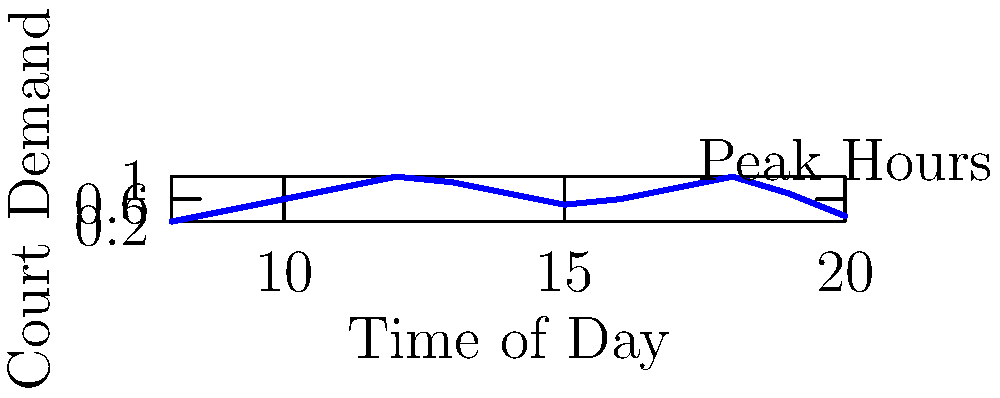Given the graph showing court demand throughout the day at your tennis club, you want to optimize court bookings to maximize usage. If you have 6 courts available and each booking lasts 2 hours, how many total court hours can be utilized during the peak demand period (demand ≥ 0.8) to maximize usage? Let's approach this step-by-step:

1) First, identify the peak demand period (demand ≥ 0.8):
   From the graph, we can see this occurs from 11:00 to 13:00 and 17:00 to 19:00.

2) Calculate the total duration of peak demand:
   (13:00 - 11:00) + (19:00 - 17:00) = 2 + 2 = 4 hours

3) Since each booking lasts 2 hours, we can fit two sets of bookings in this 4-hour period.

4) We have 6 courts available for each 2-hour slot.

5) Calculate the total court hours:
   $$ \text{Total Court Hours} = \text{Number of Courts} \times \text{Number of 2-hour slots} \times \text{Hours per slot} $$
   $$ \text{Total Court Hours} = 6 \times 2 \times 2 = 24 $$

Therefore, during the peak demand period, you can utilize 24 court hours to maximize usage.
Answer: 24 court hours 